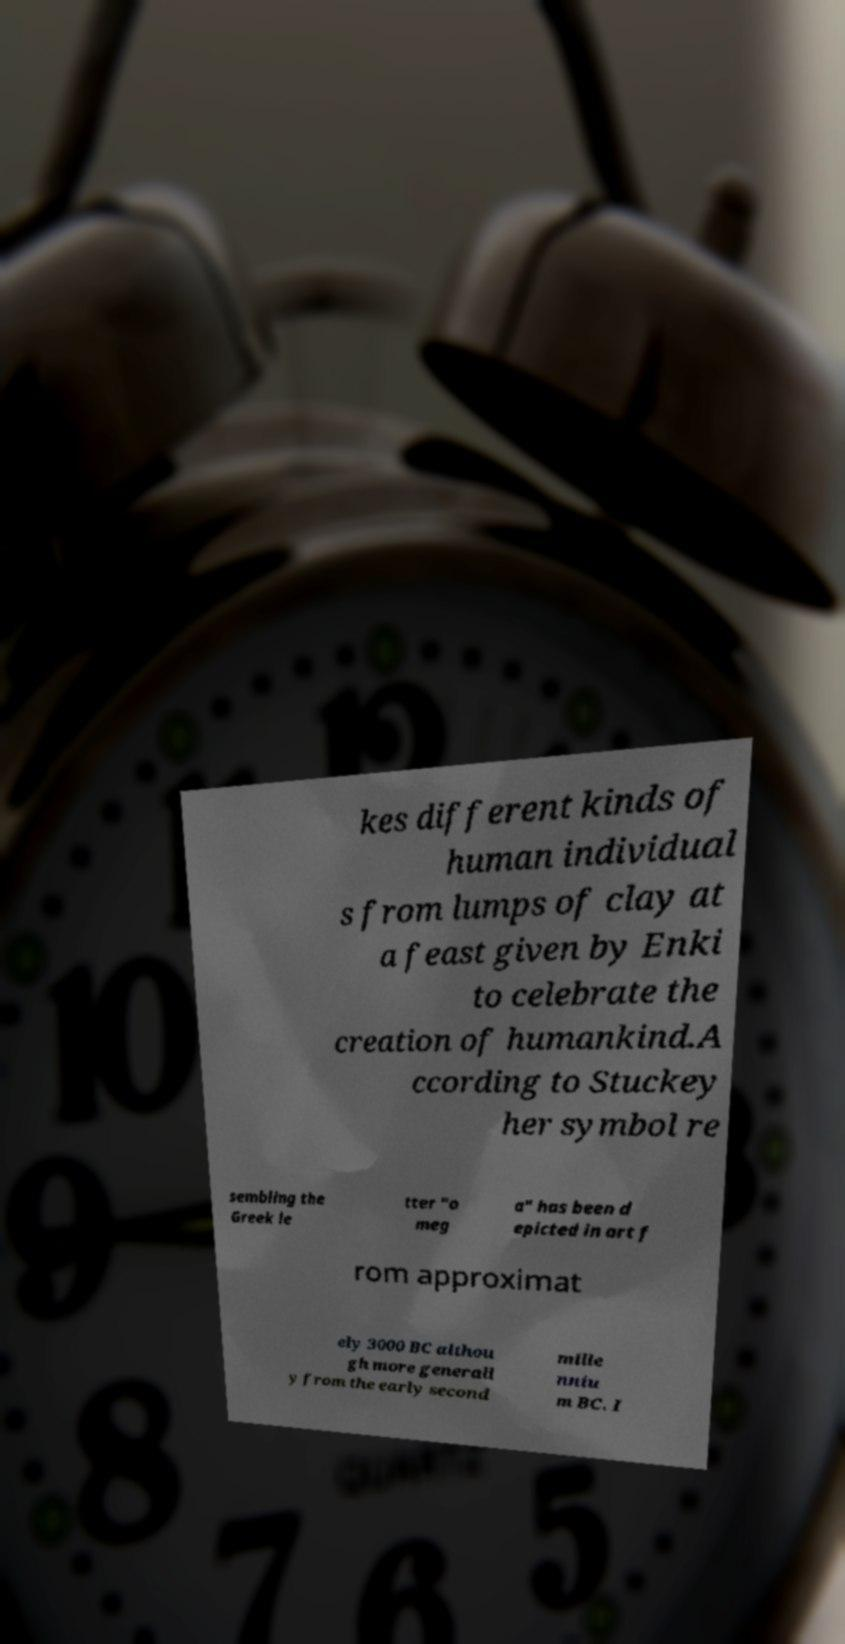Can you read and provide the text displayed in the image?This photo seems to have some interesting text. Can you extract and type it out for me? kes different kinds of human individual s from lumps of clay at a feast given by Enki to celebrate the creation of humankind.A ccording to Stuckey her symbol re sembling the Greek le tter "o meg a" has been d epicted in art f rom approximat ely 3000 BC althou gh more generall y from the early second mille nniu m BC. I 